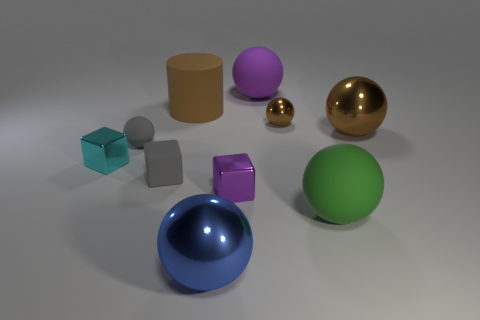Are there more tiny blocks behind the brown cylinder than green matte balls?
Provide a succinct answer. No. Do the big brown cylinder that is right of the gray sphere and the tiny brown ball have the same material?
Provide a succinct answer. No. There is a object left of the tiny sphere that is on the left side of the brown metallic ball that is on the left side of the large green sphere; what is its size?
Offer a very short reply. Small. What is the size of the cyan thing that is made of the same material as the purple block?
Give a very brief answer. Small. What is the color of the rubber object that is behind the green matte sphere and in front of the cyan metallic block?
Ensure brevity in your answer.  Gray. There is a shiny object on the right side of the tiny brown metallic object; does it have the same shape as the big matte thing to the left of the big purple matte sphere?
Provide a succinct answer. No. What is the material of the big brown thing that is right of the small brown shiny object?
Offer a terse response. Metal. There is another metallic sphere that is the same color as the small metal sphere; what size is it?
Keep it short and to the point. Large. What number of objects are large rubber objects that are in front of the large brown metallic ball or matte cubes?
Your response must be concise. 2. Are there the same number of brown metal things that are in front of the small brown sphere and gray matte things?
Keep it short and to the point. No. 